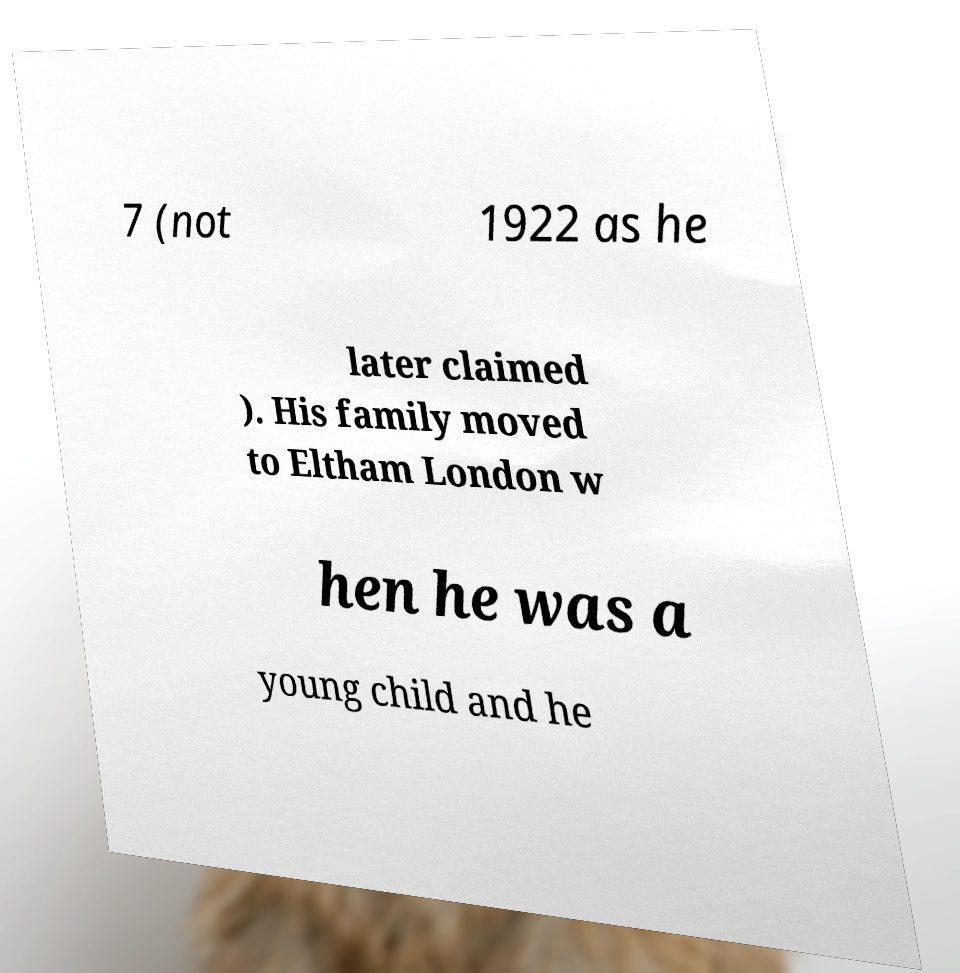Can you read and provide the text displayed in the image?This photo seems to have some interesting text. Can you extract and type it out for me? 7 (not 1922 as he later claimed ). His family moved to Eltham London w hen he was a young child and he 